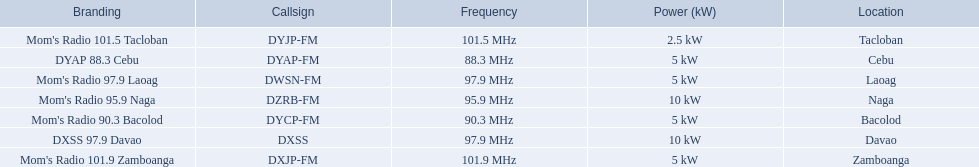What is the power capacity in kw for each team? 5 kW, 10 kW, 5 kW, 5 kW, 2.5 kW, 5 kW, 10 kW. Which is the lowest? 2.5 kW. What station has this amount of power? Mom's Radio 101.5 Tacloban. 